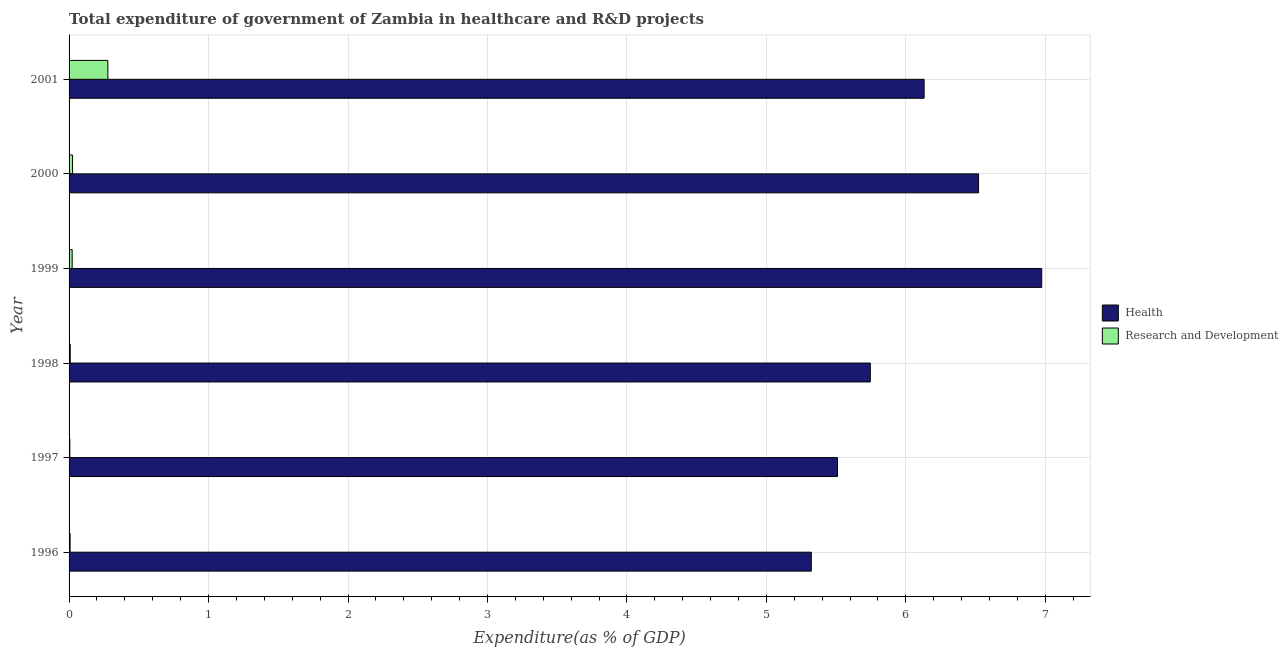How many groups of bars are there?
Make the answer very short. 6. Are the number of bars on each tick of the Y-axis equal?
Provide a succinct answer. Yes. How many bars are there on the 1st tick from the top?
Make the answer very short. 2. In how many cases, is the number of bars for a given year not equal to the number of legend labels?
Offer a terse response. 0. What is the expenditure in r&d in 1997?
Provide a short and direct response. 0.01. Across all years, what is the maximum expenditure in r&d?
Your answer should be compact. 0.28. Across all years, what is the minimum expenditure in r&d?
Make the answer very short. 0.01. In which year was the expenditure in healthcare minimum?
Offer a terse response. 1996. What is the total expenditure in healthcare in the graph?
Give a very brief answer. 36.2. What is the difference between the expenditure in r&d in 1998 and that in 1999?
Keep it short and to the point. -0.01. What is the difference between the expenditure in healthcare in 1999 and the expenditure in r&d in 2001?
Your answer should be very brief. 6.7. What is the average expenditure in r&d per year?
Your answer should be compact. 0.06. In the year 1999, what is the difference between the expenditure in r&d and expenditure in healthcare?
Provide a short and direct response. -6.95. What is the ratio of the expenditure in r&d in 1997 to that in 1998?
Your answer should be very brief. 0.64. Is the difference between the expenditure in r&d in 1997 and 2001 greater than the difference between the expenditure in healthcare in 1997 and 2001?
Your response must be concise. Yes. What is the difference between the highest and the second highest expenditure in r&d?
Ensure brevity in your answer.  0.25. What is the difference between the highest and the lowest expenditure in r&d?
Ensure brevity in your answer.  0.27. What does the 2nd bar from the top in 2001 represents?
Make the answer very short. Health. What does the 1st bar from the bottom in 2000 represents?
Your response must be concise. Health. How many bars are there?
Offer a terse response. 12. Are all the bars in the graph horizontal?
Offer a very short reply. Yes. Does the graph contain any zero values?
Your response must be concise. No. Does the graph contain grids?
Offer a very short reply. Yes. Where does the legend appear in the graph?
Keep it short and to the point. Center right. How many legend labels are there?
Provide a succinct answer. 2. How are the legend labels stacked?
Ensure brevity in your answer.  Vertical. What is the title of the graph?
Give a very brief answer. Total expenditure of government of Zambia in healthcare and R&D projects. Does "Food and tobacco" appear as one of the legend labels in the graph?
Offer a terse response. No. What is the label or title of the X-axis?
Offer a very short reply. Expenditure(as % of GDP). What is the Expenditure(as % of GDP) of Health in 1996?
Your answer should be very brief. 5.32. What is the Expenditure(as % of GDP) of Research and Development in 1996?
Ensure brevity in your answer.  0.01. What is the Expenditure(as % of GDP) in Health in 1997?
Make the answer very short. 5.51. What is the Expenditure(as % of GDP) of Research and Development in 1997?
Offer a very short reply. 0.01. What is the Expenditure(as % of GDP) in Health in 1998?
Ensure brevity in your answer.  5.75. What is the Expenditure(as % of GDP) of Research and Development in 1998?
Give a very brief answer. 0.01. What is the Expenditure(as % of GDP) in Health in 1999?
Keep it short and to the point. 6.97. What is the Expenditure(as % of GDP) of Research and Development in 1999?
Keep it short and to the point. 0.02. What is the Expenditure(as % of GDP) in Health in 2000?
Your answer should be compact. 6.52. What is the Expenditure(as % of GDP) of Research and Development in 2000?
Your answer should be very brief. 0.02. What is the Expenditure(as % of GDP) of Health in 2001?
Make the answer very short. 6.13. What is the Expenditure(as % of GDP) in Research and Development in 2001?
Make the answer very short. 0.28. Across all years, what is the maximum Expenditure(as % of GDP) in Health?
Ensure brevity in your answer.  6.97. Across all years, what is the maximum Expenditure(as % of GDP) of Research and Development?
Make the answer very short. 0.28. Across all years, what is the minimum Expenditure(as % of GDP) of Health?
Your answer should be compact. 5.32. Across all years, what is the minimum Expenditure(as % of GDP) in Research and Development?
Keep it short and to the point. 0.01. What is the total Expenditure(as % of GDP) of Health in the graph?
Give a very brief answer. 36.2. What is the total Expenditure(as % of GDP) in Research and Development in the graph?
Your response must be concise. 0.35. What is the difference between the Expenditure(as % of GDP) in Health in 1996 and that in 1997?
Your answer should be very brief. -0.19. What is the difference between the Expenditure(as % of GDP) of Research and Development in 1996 and that in 1997?
Provide a short and direct response. 0. What is the difference between the Expenditure(as % of GDP) of Health in 1996 and that in 1998?
Provide a short and direct response. -0.42. What is the difference between the Expenditure(as % of GDP) in Research and Development in 1996 and that in 1998?
Ensure brevity in your answer.  -0. What is the difference between the Expenditure(as % of GDP) in Health in 1996 and that in 1999?
Make the answer very short. -1.65. What is the difference between the Expenditure(as % of GDP) in Research and Development in 1996 and that in 1999?
Provide a succinct answer. -0.01. What is the difference between the Expenditure(as % of GDP) in Health in 1996 and that in 2000?
Make the answer very short. -1.2. What is the difference between the Expenditure(as % of GDP) of Research and Development in 1996 and that in 2000?
Ensure brevity in your answer.  -0.02. What is the difference between the Expenditure(as % of GDP) of Health in 1996 and that in 2001?
Offer a very short reply. -0.81. What is the difference between the Expenditure(as % of GDP) of Research and Development in 1996 and that in 2001?
Provide a succinct answer. -0.27. What is the difference between the Expenditure(as % of GDP) of Health in 1997 and that in 1998?
Make the answer very short. -0.24. What is the difference between the Expenditure(as % of GDP) of Research and Development in 1997 and that in 1998?
Ensure brevity in your answer.  -0. What is the difference between the Expenditure(as % of GDP) in Health in 1997 and that in 1999?
Ensure brevity in your answer.  -1.46. What is the difference between the Expenditure(as % of GDP) of Research and Development in 1997 and that in 1999?
Keep it short and to the point. -0.02. What is the difference between the Expenditure(as % of GDP) of Health in 1997 and that in 2000?
Offer a very short reply. -1.01. What is the difference between the Expenditure(as % of GDP) in Research and Development in 1997 and that in 2000?
Ensure brevity in your answer.  -0.02. What is the difference between the Expenditure(as % of GDP) in Health in 1997 and that in 2001?
Keep it short and to the point. -0.62. What is the difference between the Expenditure(as % of GDP) in Research and Development in 1997 and that in 2001?
Provide a succinct answer. -0.27. What is the difference between the Expenditure(as % of GDP) of Health in 1998 and that in 1999?
Make the answer very short. -1.23. What is the difference between the Expenditure(as % of GDP) of Research and Development in 1998 and that in 1999?
Make the answer very short. -0.01. What is the difference between the Expenditure(as % of GDP) in Health in 1998 and that in 2000?
Your answer should be compact. -0.78. What is the difference between the Expenditure(as % of GDP) of Research and Development in 1998 and that in 2000?
Offer a very short reply. -0.02. What is the difference between the Expenditure(as % of GDP) of Health in 1998 and that in 2001?
Provide a short and direct response. -0.39. What is the difference between the Expenditure(as % of GDP) in Research and Development in 1998 and that in 2001?
Provide a succinct answer. -0.27. What is the difference between the Expenditure(as % of GDP) of Health in 1999 and that in 2000?
Offer a terse response. 0.45. What is the difference between the Expenditure(as % of GDP) of Research and Development in 1999 and that in 2000?
Offer a very short reply. -0. What is the difference between the Expenditure(as % of GDP) in Health in 1999 and that in 2001?
Provide a short and direct response. 0.84. What is the difference between the Expenditure(as % of GDP) in Research and Development in 1999 and that in 2001?
Ensure brevity in your answer.  -0.26. What is the difference between the Expenditure(as % of GDP) in Health in 2000 and that in 2001?
Make the answer very short. 0.39. What is the difference between the Expenditure(as % of GDP) of Research and Development in 2000 and that in 2001?
Your response must be concise. -0.25. What is the difference between the Expenditure(as % of GDP) in Health in 1996 and the Expenditure(as % of GDP) in Research and Development in 1997?
Your response must be concise. 5.32. What is the difference between the Expenditure(as % of GDP) in Health in 1996 and the Expenditure(as % of GDP) in Research and Development in 1998?
Provide a short and direct response. 5.31. What is the difference between the Expenditure(as % of GDP) in Health in 1996 and the Expenditure(as % of GDP) in Research and Development in 1999?
Make the answer very short. 5.3. What is the difference between the Expenditure(as % of GDP) in Health in 1996 and the Expenditure(as % of GDP) in Research and Development in 2000?
Give a very brief answer. 5.3. What is the difference between the Expenditure(as % of GDP) in Health in 1996 and the Expenditure(as % of GDP) in Research and Development in 2001?
Keep it short and to the point. 5.04. What is the difference between the Expenditure(as % of GDP) in Health in 1997 and the Expenditure(as % of GDP) in Research and Development in 1998?
Provide a short and direct response. 5.5. What is the difference between the Expenditure(as % of GDP) in Health in 1997 and the Expenditure(as % of GDP) in Research and Development in 1999?
Offer a very short reply. 5.49. What is the difference between the Expenditure(as % of GDP) of Health in 1997 and the Expenditure(as % of GDP) of Research and Development in 2000?
Keep it short and to the point. 5.48. What is the difference between the Expenditure(as % of GDP) of Health in 1997 and the Expenditure(as % of GDP) of Research and Development in 2001?
Ensure brevity in your answer.  5.23. What is the difference between the Expenditure(as % of GDP) of Health in 1998 and the Expenditure(as % of GDP) of Research and Development in 1999?
Give a very brief answer. 5.72. What is the difference between the Expenditure(as % of GDP) of Health in 1998 and the Expenditure(as % of GDP) of Research and Development in 2000?
Your answer should be very brief. 5.72. What is the difference between the Expenditure(as % of GDP) in Health in 1998 and the Expenditure(as % of GDP) in Research and Development in 2001?
Your answer should be very brief. 5.47. What is the difference between the Expenditure(as % of GDP) in Health in 1999 and the Expenditure(as % of GDP) in Research and Development in 2000?
Offer a very short reply. 6.95. What is the difference between the Expenditure(as % of GDP) in Health in 1999 and the Expenditure(as % of GDP) in Research and Development in 2001?
Provide a short and direct response. 6.7. What is the difference between the Expenditure(as % of GDP) in Health in 2000 and the Expenditure(as % of GDP) in Research and Development in 2001?
Provide a short and direct response. 6.24. What is the average Expenditure(as % of GDP) in Health per year?
Provide a short and direct response. 6.03. What is the average Expenditure(as % of GDP) of Research and Development per year?
Keep it short and to the point. 0.06. In the year 1996, what is the difference between the Expenditure(as % of GDP) of Health and Expenditure(as % of GDP) of Research and Development?
Provide a short and direct response. 5.31. In the year 1997, what is the difference between the Expenditure(as % of GDP) in Health and Expenditure(as % of GDP) in Research and Development?
Your response must be concise. 5.5. In the year 1998, what is the difference between the Expenditure(as % of GDP) of Health and Expenditure(as % of GDP) of Research and Development?
Your response must be concise. 5.74. In the year 1999, what is the difference between the Expenditure(as % of GDP) in Health and Expenditure(as % of GDP) in Research and Development?
Your answer should be compact. 6.95. In the year 2000, what is the difference between the Expenditure(as % of GDP) in Health and Expenditure(as % of GDP) in Research and Development?
Offer a terse response. 6.5. In the year 2001, what is the difference between the Expenditure(as % of GDP) in Health and Expenditure(as % of GDP) in Research and Development?
Your answer should be compact. 5.85. What is the ratio of the Expenditure(as % of GDP) of Health in 1996 to that in 1997?
Offer a terse response. 0.97. What is the ratio of the Expenditure(as % of GDP) of Research and Development in 1996 to that in 1997?
Provide a succinct answer. 1.35. What is the ratio of the Expenditure(as % of GDP) of Health in 1996 to that in 1998?
Keep it short and to the point. 0.93. What is the ratio of the Expenditure(as % of GDP) in Research and Development in 1996 to that in 1998?
Your answer should be compact. 0.87. What is the ratio of the Expenditure(as % of GDP) of Health in 1996 to that in 1999?
Make the answer very short. 0.76. What is the ratio of the Expenditure(as % of GDP) in Research and Development in 1996 to that in 1999?
Give a very brief answer. 0.33. What is the ratio of the Expenditure(as % of GDP) in Health in 1996 to that in 2000?
Offer a very short reply. 0.82. What is the ratio of the Expenditure(as % of GDP) in Research and Development in 1996 to that in 2000?
Give a very brief answer. 0.3. What is the ratio of the Expenditure(as % of GDP) in Health in 1996 to that in 2001?
Keep it short and to the point. 0.87. What is the ratio of the Expenditure(as % of GDP) of Research and Development in 1996 to that in 2001?
Make the answer very short. 0.03. What is the ratio of the Expenditure(as % of GDP) of Research and Development in 1997 to that in 1998?
Offer a very short reply. 0.64. What is the ratio of the Expenditure(as % of GDP) of Health in 1997 to that in 1999?
Provide a short and direct response. 0.79. What is the ratio of the Expenditure(as % of GDP) in Research and Development in 1997 to that in 1999?
Provide a short and direct response. 0.24. What is the ratio of the Expenditure(as % of GDP) of Health in 1997 to that in 2000?
Offer a very short reply. 0.84. What is the ratio of the Expenditure(as % of GDP) of Research and Development in 1997 to that in 2000?
Your answer should be very brief. 0.22. What is the ratio of the Expenditure(as % of GDP) of Health in 1997 to that in 2001?
Ensure brevity in your answer.  0.9. What is the ratio of the Expenditure(as % of GDP) in Research and Development in 1997 to that in 2001?
Keep it short and to the point. 0.02. What is the ratio of the Expenditure(as % of GDP) in Health in 1998 to that in 1999?
Your answer should be compact. 0.82. What is the ratio of the Expenditure(as % of GDP) in Research and Development in 1998 to that in 1999?
Provide a short and direct response. 0.38. What is the ratio of the Expenditure(as % of GDP) in Health in 1998 to that in 2000?
Your answer should be compact. 0.88. What is the ratio of the Expenditure(as % of GDP) of Research and Development in 1998 to that in 2000?
Offer a very short reply. 0.34. What is the ratio of the Expenditure(as % of GDP) in Health in 1998 to that in 2001?
Offer a terse response. 0.94. What is the ratio of the Expenditure(as % of GDP) of Research and Development in 1998 to that in 2001?
Offer a terse response. 0.03. What is the ratio of the Expenditure(as % of GDP) in Health in 1999 to that in 2000?
Ensure brevity in your answer.  1.07. What is the ratio of the Expenditure(as % of GDP) of Research and Development in 1999 to that in 2000?
Make the answer very short. 0.89. What is the ratio of the Expenditure(as % of GDP) in Health in 1999 to that in 2001?
Offer a terse response. 1.14. What is the ratio of the Expenditure(as % of GDP) of Research and Development in 1999 to that in 2001?
Make the answer very short. 0.08. What is the ratio of the Expenditure(as % of GDP) in Health in 2000 to that in 2001?
Make the answer very short. 1.06. What is the ratio of the Expenditure(as % of GDP) of Research and Development in 2000 to that in 2001?
Your answer should be very brief. 0.09. What is the difference between the highest and the second highest Expenditure(as % of GDP) of Health?
Your response must be concise. 0.45. What is the difference between the highest and the second highest Expenditure(as % of GDP) in Research and Development?
Keep it short and to the point. 0.25. What is the difference between the highest and the lowest Expenditure(as % of GDP) of Health?
Keep it short and to the point. 1.65. What is the difference between the highest and the lowest Expenditure(as % of GDP) in Research and Development?
Your answer should be very brief. 0.27. 